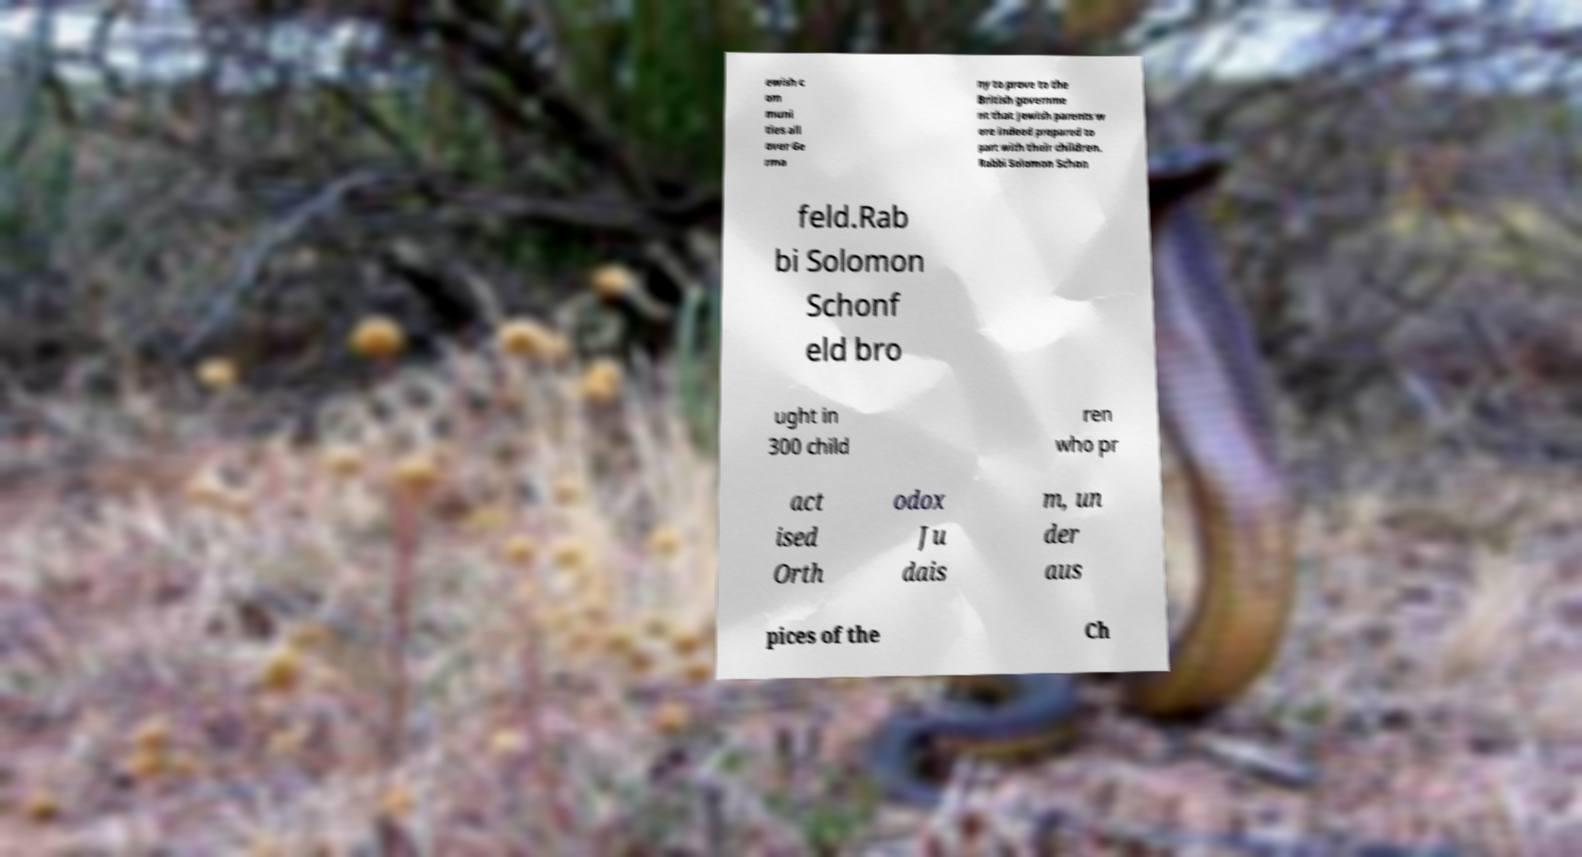Please read and relay the text visible in this image. What does it say? ewish c om muni ties all over Ge rma ny to prove to the British governme nt that Jewish parents w ere indeed prepared to part with their children. Rabbi Solomon Schon feld.Rab bi Solomon Schonf eld bro ught in 300 child ren who pr act ised Orth odox Ju dais m, un der aus pices of the Ch 